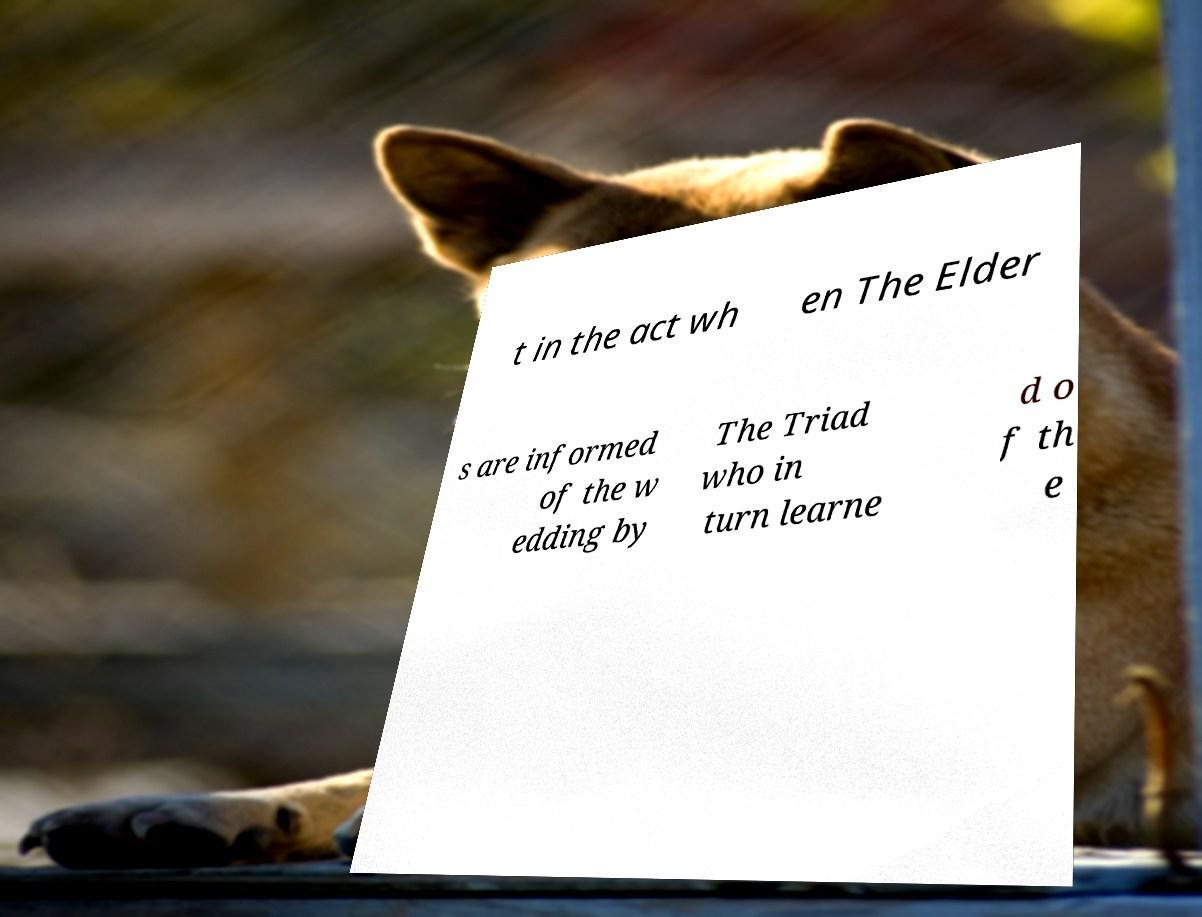There's text embedded in this image that I need extracted. Can you transcribe it verbatim? t in the act wh en The Elder s are informed of the w edding by The Triad who in turn learne d o f th e 